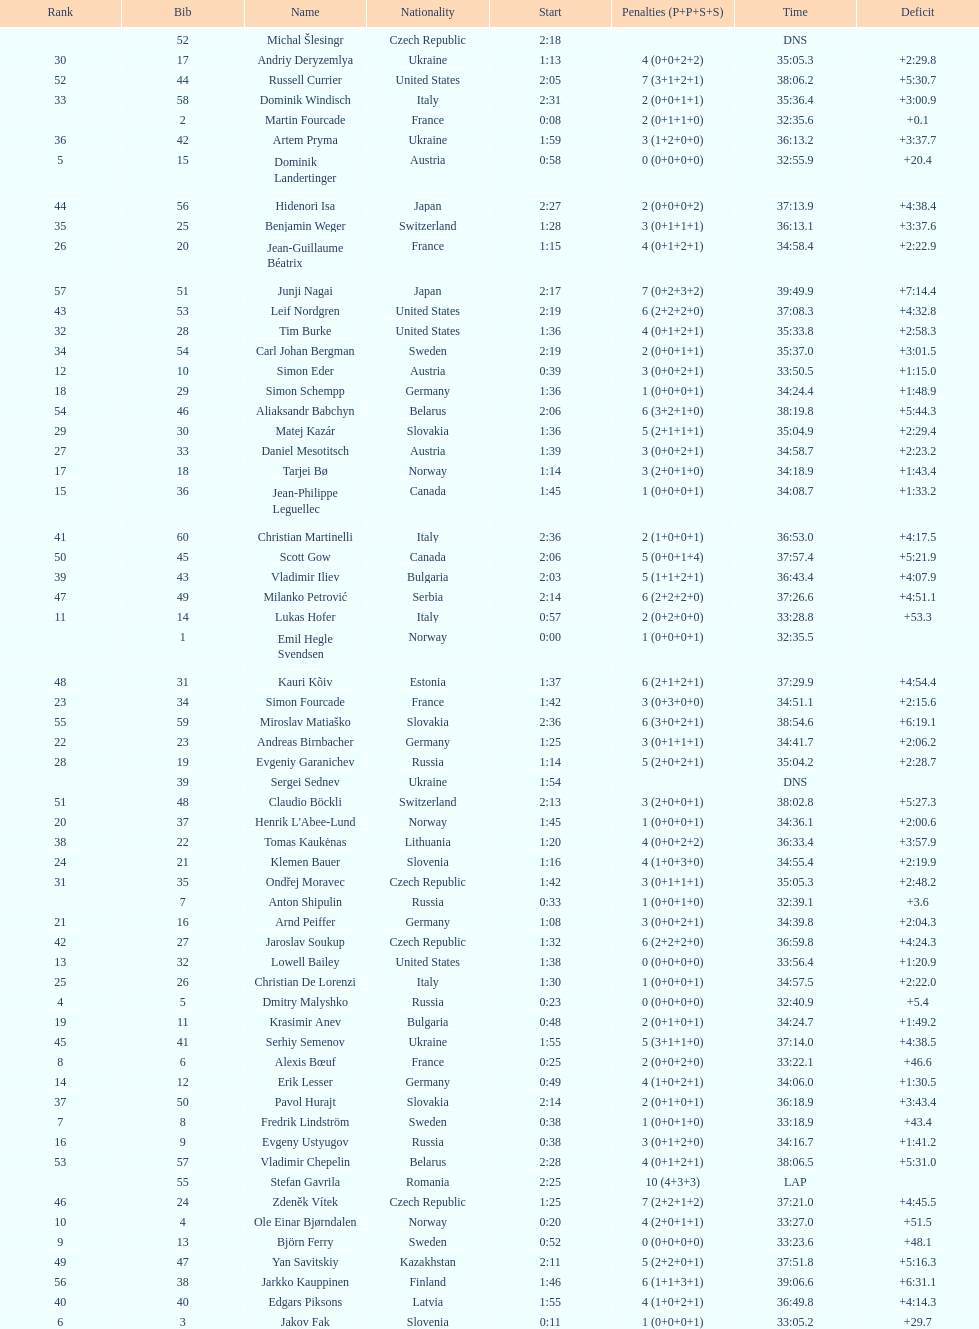How many united states competitors did not win medals? 4. 